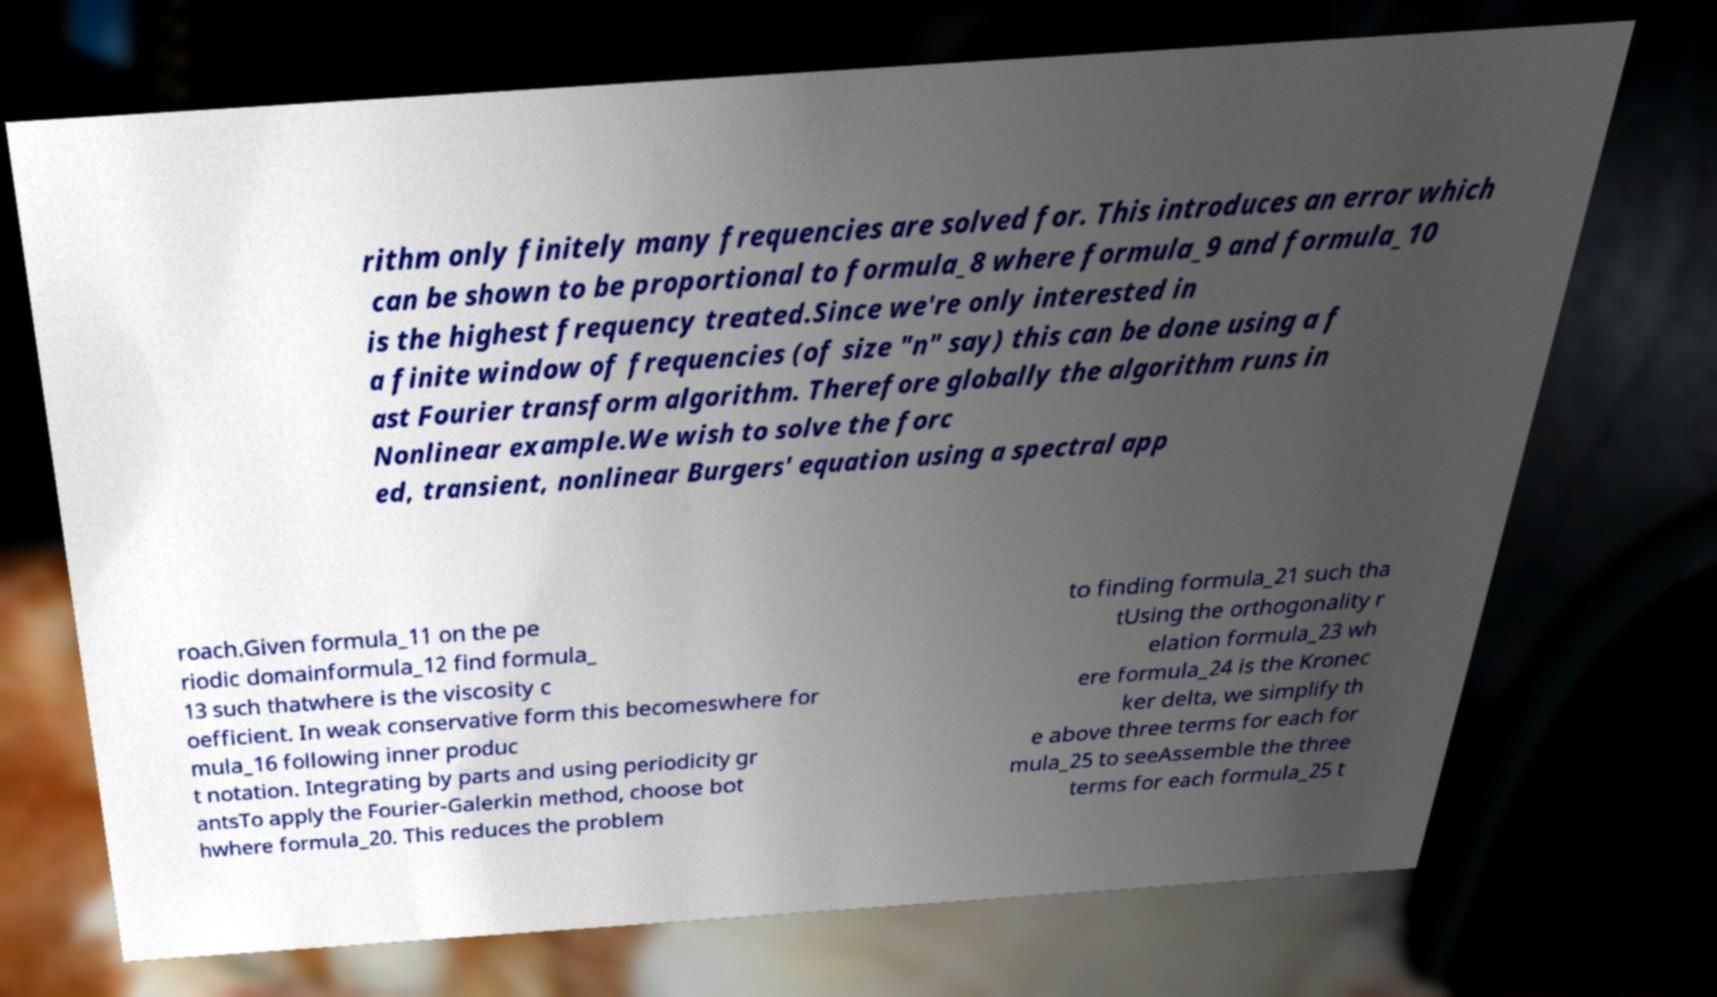Could you extract and type out the text from this image? rithm only finitely many frequencies are solved for. This introduces an error which can be shown to be proportional to formula_8 where formula_9 and formula_10 is the highest frequency treated.Since we're only interested in a finite window of frequencies (of size "n" say) this can be done using a f ast Fourier transform algorithm. Therefore globally the algorithm runs in Nonlinear example.We wish to solve the forc ed, transient, nonlinear Burgers' equation using a spectral app roach.Given formula_11 on the pe riodic domainformula_12 find formula_ 13 such thatwhere is the viscosity c oefficient. In weak conservative form this becomeswhere for mula_16 following inner produc t notation. Integrating by parts and using periodicity gr antsTo apply the Fourier-Galerkin method, choose bot hwhere formula_20. This reduces the problem to finding formula_21 such tha tUsing the orthogonality r elation formula_23 wh ere formula_24 is the Kronec ker delta, we simplify th e above three terms for each for mula_25 to seeAssemble the three terms for each formula_25 t 